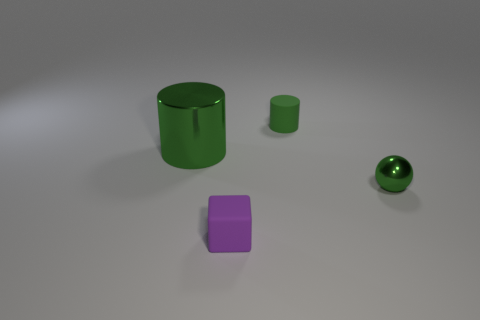Is there a small brown thing that has the same material as the big cylinder?
Your answer should be compact. No. What is the shape of the small purple thing?
Offer a very short reply. Cube. There is another object that is the same material as the large object; what is its color?
Your answer should be very brief. Green. What number of blue things are big matte cylinders or metallic cylinders?
Your response must be concise. 0. Are there more green rubber objects than green cylinders?
Offer a terse response. No. How many objects are green metal objects that are behind the tiny metallic ball or tiny things in front of the big cylinder?
Ensure brevity in your answer.  3. What is the color of the cylinder that is the same size as the green metal sphere?
Offer a terse response. Green. Is the purple block made of the same material as the green ball?
Your answer should be very brief. No. The small green object that is behind the small shiny sphere right of the small purple rubber cube is made of what material?
Offer a terse response. Rubber. Are there more shiny things that are in front of the big green object than tiny yellow cubes?
Provide a succinct answer. Yes. 